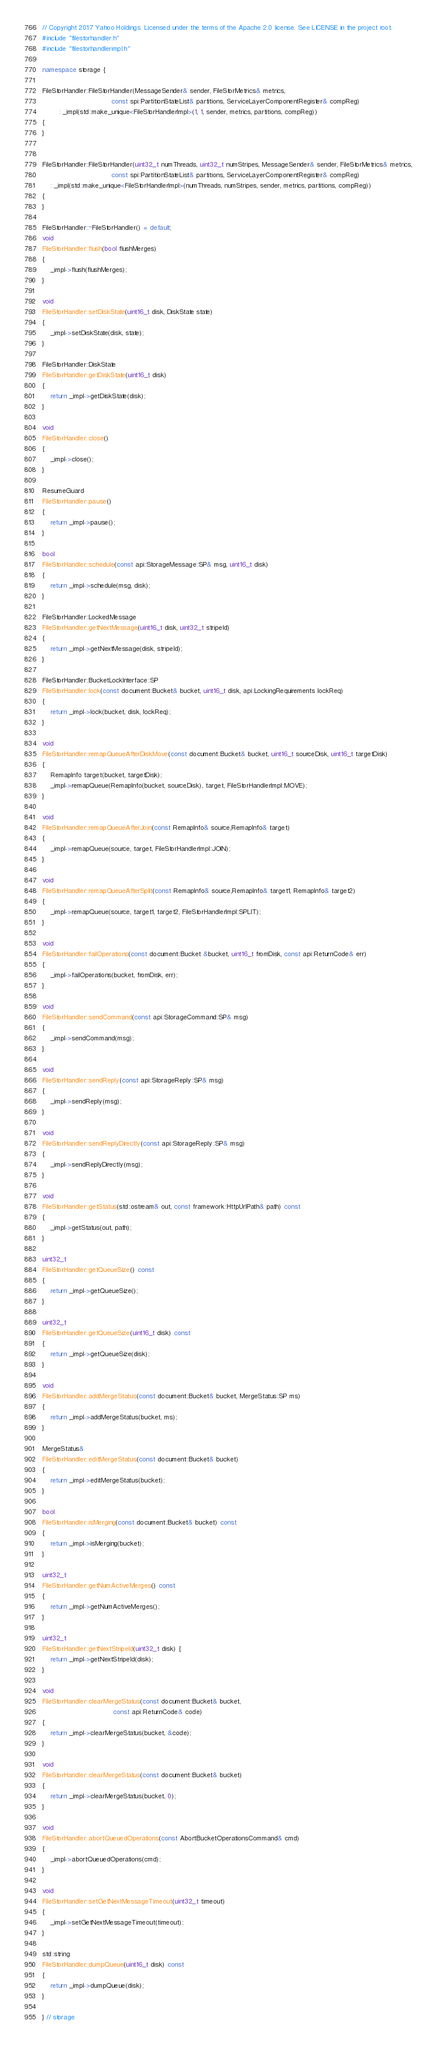Convert code to text. <code><loc_0><loc_0><loc_500><loc_500><_C++_>// Copyright 2017 Yahoo Holdings. Licensed under the terms of the Apache 2.0 license. See LICENSE in the project root.
#include "filestorhandler.h"
#include "filestorhandlerimpl.h"

namespace storage {

FileStorHandler::FileStorHandler(MessageSender& sender, FileStorMetrics& metrics,
                                 const spi::PartitionStateList& partitions, ServiceLayerComponentRegister& compReg)
        : _impl(std::make_unique<FileStorHandlerImpl>(1, 1, sender, metrics, partitions, compReg))
{
}


FileStorHandler::FileStorHandler(uint32_t numThreads, uint32_t numStripes, MessageSender& sender, FileStorMetrics& metrics,
                                 const spi::PartitionStateList& partitions, ServiceLayerComponentRegister& compReg)
    : _impl(std::make_unique<FileStorHandlerImpl>(numThreads, numStripes, sender, metrics, partitions, compReg))
{
}

FileStorHandler::~FileStorHandler() = default;
void
FileStorHandler::flush(bool flushMerges)
{
    _impl->flush(flushMerges);
}

void
FileStorHandler::setDiskState(uint16_t disk, DiskState state)
{
    _impl->setDiskState(disk, state);
}

FileStorHandler::DiskState
FileStorHandler::getDiskState(uint16_t disk)
{
    return _impl->getDiskState(disk);
}

void
FileStorHandler::close()
{
    _impl->close();
}

ResumeGuard
FileStorHandler::pause()
{
    return _impl->pause();
}

bool
FileStorHandler::schedule(const api::StorageMessage::SP& msg, uint16_t disk)
{
    return _impl->schedule(msg, disk);
}

FileStorHandler::LockedMessage
FileStorHandler::getNextMessage(uint16_t disk, uint32_t stripeId)
{
    return _impl->getNextMessage(disk, stripeId);
}

FileStorHandler::BucketLockInterface::SP
FileStorHandler::lock(const document::Bucket& bucket, uint16_t disk, api::LockingRequirements lockReq)
{
    return _impl->lock(bucket, disk, lockReq);
}

void
FileStorHandler::remapQueueAfterDiskMove(const document::Bucket& bucket, uint16_t sourceDisk, uint16_t targetDisk)
{
    RemapInfo target(bucket, targetDisk);
    _impl->remapQueue(RemapInfo(bucket, sourceDisk), target, FileStorHandlerImpl::MOVE);
}

void
FileStorHandler::remapQueueAfterJoin(const RemapInfo& source,RemapInfo& target)
{
    _impl->remapQueue(source, target, FileStorHandlerImpl::JOIN);
}

void
FileStorHandler::remapQueueAfterSplit(const RemapInfo& source,RemapInfo& target1, RemapInfo& target2)
{
    _impl->remapQueue(source, target1, target2, FileStorHandlerImpl::SPLIT);
}

void
FileStorHandler::failOperations(const document::Bucket &bucket, uint16_t fromDisk, const api::ReturnCode& err)
{
    _impl->failOperations(bucket, fromDisk, err);
}

void
FileStorHandler::sendCommand(const api::StorageCommand::SP& msg)
{
    _impl->sendCommand(msg);
}

void
FileStorHandler::sendReply(const api::StorageReply::SP& msg)
{
    _impl->sendReply(msg);
}

void
FileStorHandler::sendReplyDirectly(const api::StorageReply::SP& msg)
{
    _impl->sendReplyDirectly(msg);
}

void
FileStorHandler::getStatus(std::ostream& out, const framework::HttpUrlPath& path) const
{
    _impl->getStatus(out, path);
}

uint32_t
FileStorHandler::getQueueSize() const
{
    return _impl->getQueueSize();
}

uint32_t
FileStorHandler::getQueueSize(uint16_t disk) const
{
    return _impl->getQueueSize(disk);
}

void
FileStorHandler::addMergeStatus(const document::Bucket& bucket, MergeStatus::SP ms)
{
    return _impl->addMergeStatus(bucket, ms);
}

MergeStatus&
FileStorHandler::editMergeStatus(const document::Bucket& bucket)
{
    return _impl->editMergeStatus(bucket);
}

bool
FileStorHandler::isMerging(const document::Bucket& bucket) const
{
    return _impl->isMerging(bucket);
}

uint32_t
FileStorHandler::getNumActiveMerges() const
{
    return _impl->getNumActiveMerges();
}

uint32_t
FileStorHandler::getNextStripeId(uint32_t disk) {
    return _impl->getNextStripeId(disk);
}

void
FileStorHandler::clearMergeStatus(const document::Bucket& bucket,
                                  const api::ReturnCode& code)
{
    return _impl->clearMergeStatus(bucket, &code);
}

void
FileStorHandler::clearMergeStatus(const document::Bucket& bucket)
{
    return _impl->clearMergeStatus(bucket, 0);
}

void
FileStorHandler::abortQueuedOperations(const AbortBucketOperationsCommand& cmd)
{
    _impl->abortQueuedOperations(cmd);
}

void
FileStorHandler::setGetNextMessageTimeout(uint32_t timeout)
{
    _impl->setGetNextMessageTimeout(timeout);
}

std::string
FileStorHandler::dumpQueue(uint16_t disk) const
{
    return _impl->dumpQueue(disk);
}

} // storage
</code> 